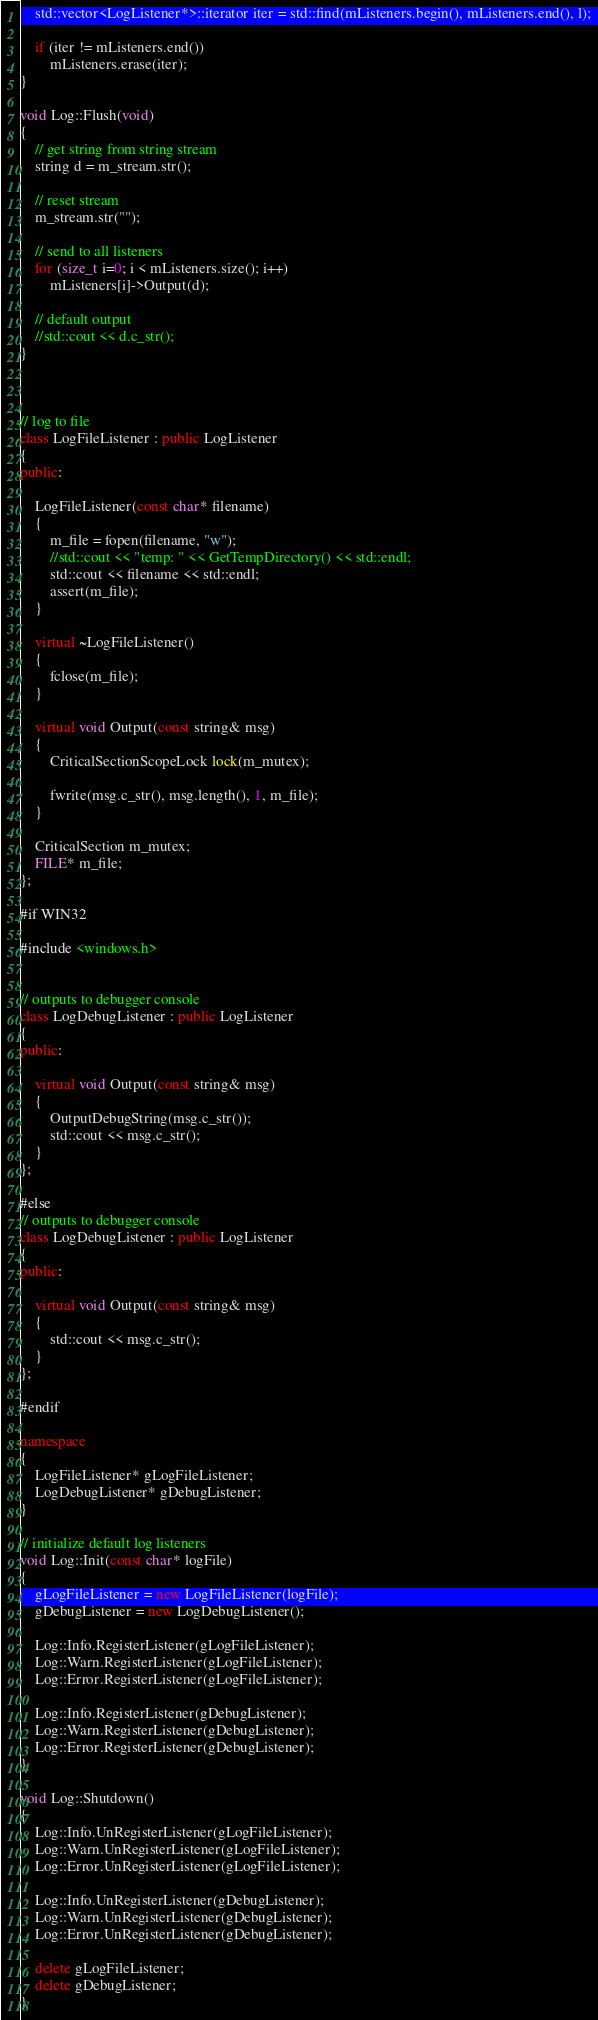<code> <loc_0><loc_0><loc_500><loc_500><_C++_>	std::vector<LogListener*>::iterator iter = std::find(mListeners.begin(), mListeners.end(), l);

	if (iter != mListeners.end())
		mListeners.erase(iter);
}

void Log::Flush(void)
{
	// get string from string stream
	string d = m_stream.str();
	
	// reset stream
	m_stream.str("");

	// send to all listeners
	for (size_t i=0; i < mListeners.size(); i++)
		mListeners[i]->Output(d);

	// default output
	//std::cout << d.c_str();
}



// log to file
class LogFileListener : public LogListener
{
public:

	LogFileListener(const char* filename)
	{
		m_file = fopen(filename, "w");
		//std::cout << "temp: " << GetTempDirectory() << std::endl;
		std::cout << filename << std::endl;
		assert(m_file);
	}

	virtual ~LogFileListener()
	{
		fclose(m_file);
	}

	virtual void Output(const string& msg)
	{	
		CriticalSectionScopeLock lock(m_mutex);

		fwrite(msg.c_str(), msg.length(), 1, m_file);
	}

	CriticalSection m_mutex;
	FILE* m_file;
};

#if WIN32

#include <windows.h>


// outputs to debugger console
class LogDebugListener : public LogListener
{
public:

	virtual void Output(const string& msg)
	{
		OutputDebugString(msg.c_str());
		std::cout << msg.c_str();
	}
};

#else
// outputs to debugger console
class LogDebugListener : public LogListener
{
public:
	
	virtual void Output(const string& msg)
	{
		std::cout << msg.c_str();
	}
};

#endif

namespace
{
	LogFileListener* gLogFileListener;
	LogDebugListener* gDebugListener;
}

// initialize default log listeners
void Log::Init(const char* logFile)
{
	gLogFileListener = new LogFileListener(logFile);
	gDebugListener = new LogDebugListener();
										   
	Log::Info.RegisterListener(gLogFileListener);
	Log::Warn.RegisterListener(gLogFileListener);
	Log::Error.RegisterListener(gLogFileListener);

	Log::Info.RegisterListener(gDebugListener);
	Log::Warn.RegisterListener(gDebugListener);
	Log::Error.RegisterListener(gDebugListener);
}

void Log::Shutdown()
{
	Log::Info.UnRegisterListener(gLogFileListener);
	Log::Warn.UnRegisterListener(gLogFileListener);
	Log::Error.UnRegisterListener(gLogFileListener);

	Log::Info.UnRegisterListener(gDebugListener);
	Log::Warn.UnRegisterListener(gDebugListener);
	Log::Error.UnRegisterListener(gDebugListener);

	delete gLogFileListener;
	delete gDebugListener;	
}
</code> 